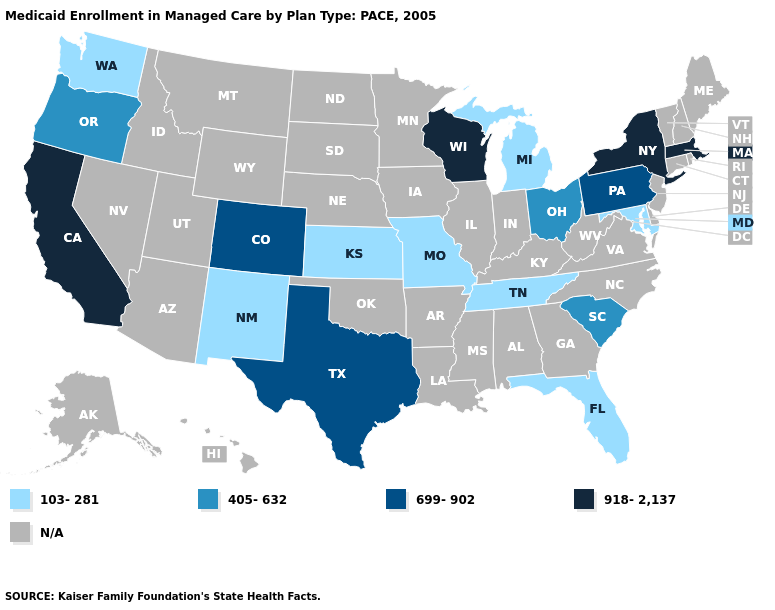Is the legend a continuous bar?
Write a very short answer. No. Which states hav the highest value in the MidWest?
Give a very brief answer. Wisconsin. Name the states that have a value in the range 918-2,137?
Short answer required. California, Massachusetts, New York, Wisconsin. Among the states that border Indiana , does Ohio have the lowest value?
Keep it brief. No. Name the states that have a value in the range 405-632?
Be succinct. Ohio, Oregon, South Carolina. What is the value of Florida?
Short answer required. 103-281. Name the states that have a value in the range 699-902?
Answer briefly. Colorado, Pennsylvania, Texas. Which states have the lowest value in the USA?
Short answer required. Florida, Kansas, Maryland, Michigan, Missouri, New Mexico, Tennessee, Washington. What is the highest value in states that border New Hampshire?
Be succinct. 918-2,137. What is the highest value in the USA?
Short answer required. 918-2,137. What is the value of Montana?
Be succinct. N/A. What is the value of Maryland?
Keep it brief. 103-281. What is the highest value in the USA?
Keep it brief. 918-2,137. What is the value of Georgia?
Short answer required. N/A. Among the states that border Missouri , which have the highest value?
Keep it brief. Kansas, Tennessee. 